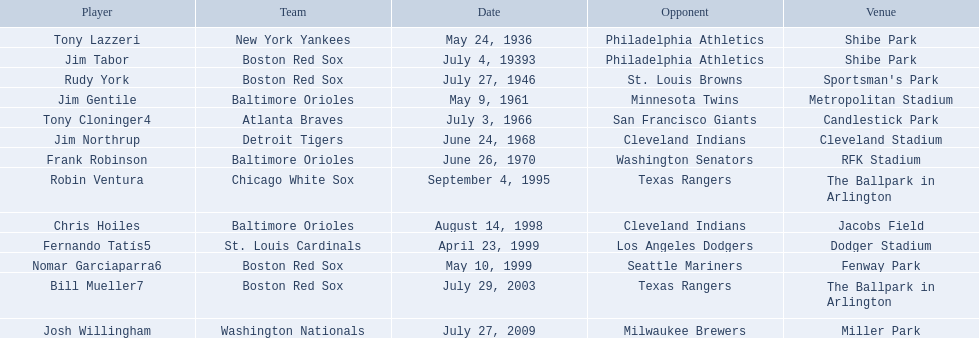Who are all the opponents? Philadelphia Athletics, Philadelphia Athletics, St. Louis Browns, Minnesota Twins, San Francisco Giants, Cleveland Indians, Washington Senators, Texas Rangers, Cleveland Indians, Los Angeles Dodgers, Seattle Mariners, Texas Rangers, Milwaukee Brewers. What teams played on july 27, 1946? Boston Red Sox, July 27, 1946, St. Louis Browns. Who was the opponent in this game? St. Louis Browns. Which teams were involved? New York Yankees, Boston Red Sox, Boston Red Sox, Baltimore Orioles, Atlanta Braves, Detroit Tigers, Baltimore Orioles, Chicago White Sox, Baltimore Orioles, St. Louis Cardinals, Boston Red Sox, Boston Red Sox, Washington Nationals. Who were their adversaries? Philadelphia Athletics, Philadelphia Athletics, St. Louis Browns, Minnesota Twins, San Francisco Giants, Cleveland Indians, Washington Senators, Texas Rangers, Cleveland Indians, Los Angeles Dodgers, Seattle Mariners, Texas Rangers, Milwaukee Brewers. When were the matches held? May 24, 1936, July 4, 19393, July 27, 1946, May 9, 1961, July 3, 1966, June 24, 1968, June 26, 1970, September 4, 1995, August 14, 1998, April 23, 1999, May 10, 1999, July 29, 2003, July 27, 2009. On july 27, 1946, which team faced off against the red sox? St. Louis Browns. 